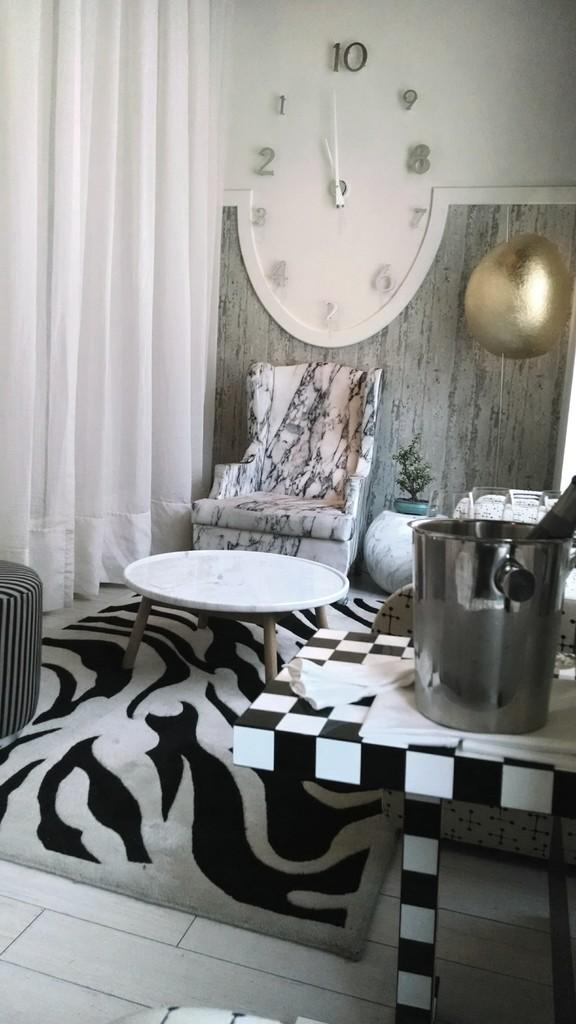<image>
Write a terse but informative summary of the picture. a clock that is on the wall with a big letter 10 